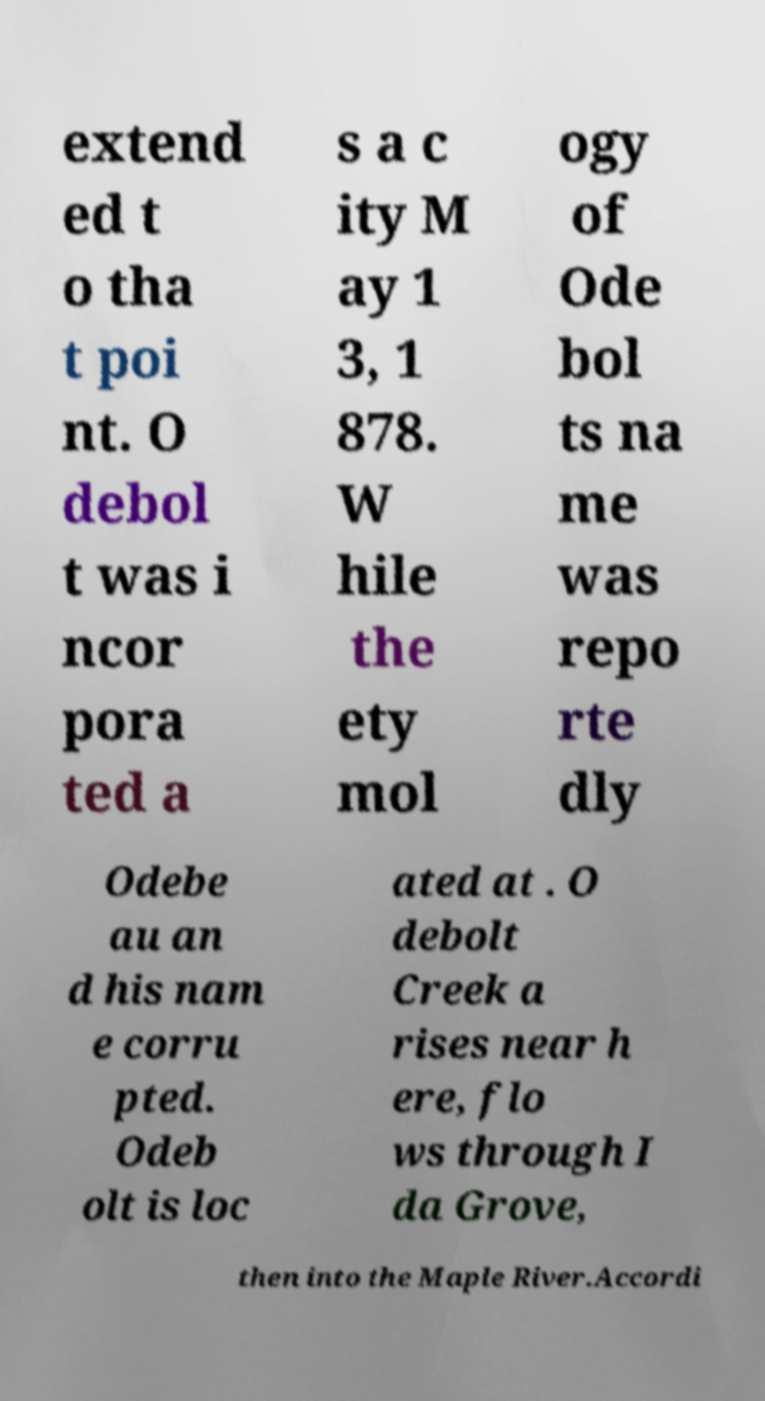I need the written content from this picture converted into text. Can you do that? extend ed t o tha t poi nt. O debol t was i ncor pora ted a s a c ity M ay 1 3, 1 878. W hile the ety mol ogy of Ode bol ts na me was repo rte dly Odebe au an d his nam e corru pted. Odeb olt is loc ated at . O debolt Creek a rises near h ere, flo ws through I da Grove, then into the Maple River.Accordi 